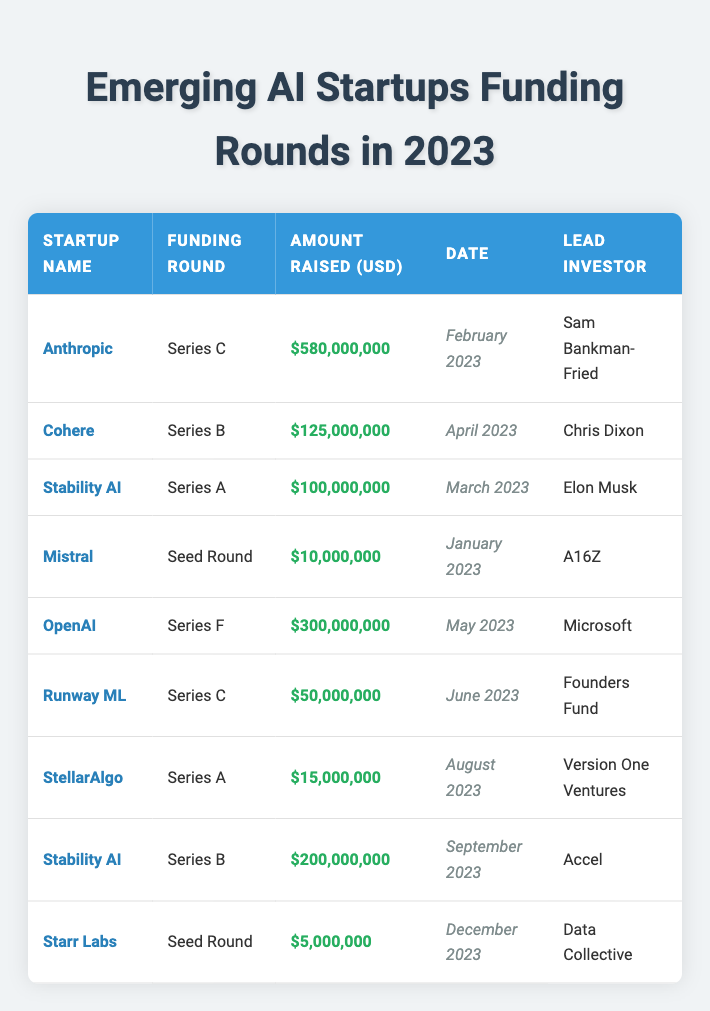What is the total amount raised by Stability AI in 2023? Stability AI has two entries in the table; one is $100,000,000 in Series A and the other is $200,000,000 in Series B. To get the total, we add these amounts: $100,000,000 + $200,000,000 = $300,000,000.
Answer: $300,000,000 Which startup raised the highest amount of funding in 2023? The largest funding round is attributed to Anthropic, with a total of $580,000,000 raised in Series C in February 2023.
Answer: Anthropic How many startups had a funding round with an amount raised exceeding $200 million? The startups that raised over $200 million are Anthropic ($580 million) and Stability AI ($200 million). Initially, we see Anthropic and then check for others but only one qualifies, so there are two startups.
Answer: 2 Did Mistral have a funding round in 2023, and if so, what was the amount? Yes, Mistral had a Seed Round in January 2023 where it raised $10,000,000, as indicated in the table.
Answer: Yes, $10,000,000 What is the average amount raised across all funding rounds listed in the table? First, we sum all the amounts raised: $580,000,000 + $125,000,000 + $100,000,000 + $10,000,000 + $300,000,000 + $50,000,000 + $15,000,000 + $200,000,000 + $5,000,000 = $1,390,000,000. There are 9 rounds, so the average is $1,390,000,000 / 9 ≈ $154,444,444.44.
Answer: Approximately $154,444,444 What was the latest funding round date recorded in the table? The latest date in the table is December 2023 for Starr Labs, which had a Seed Round.
Answer: December 2023 Which investor led the most significant funding round, and how much was raised? The most significant funding round led by an investor was for Anthropic, with $580,000,000 from Sam Bankman-Fried in February 2023.
Answer: Sam Bankman-Fried, $580,000,000 Was there more than one startup that raised funding in January 2023? No, only Mistral had a funding round in January 2023, with $10,000,000 raised.
Answer: No How many seed rounds were listed in the table, and what were their amounts raised? There are two seed rounds: Mistral with $10,000,000 and Starr Labs with $5,000,000. We add these amounts for reference.
Answer: 2; $10,000,000 and $5,000,000 What percentage of the total funding raised is attributed to OpenAI? OpenAI raised $300,000,000. The total amount raised is $1,390,000,000. To find the percentage, we calculate (300,000,000 / 1,390,000,000) * 100 ≈ 21.6%.
Answer: Approximately 21.6% 